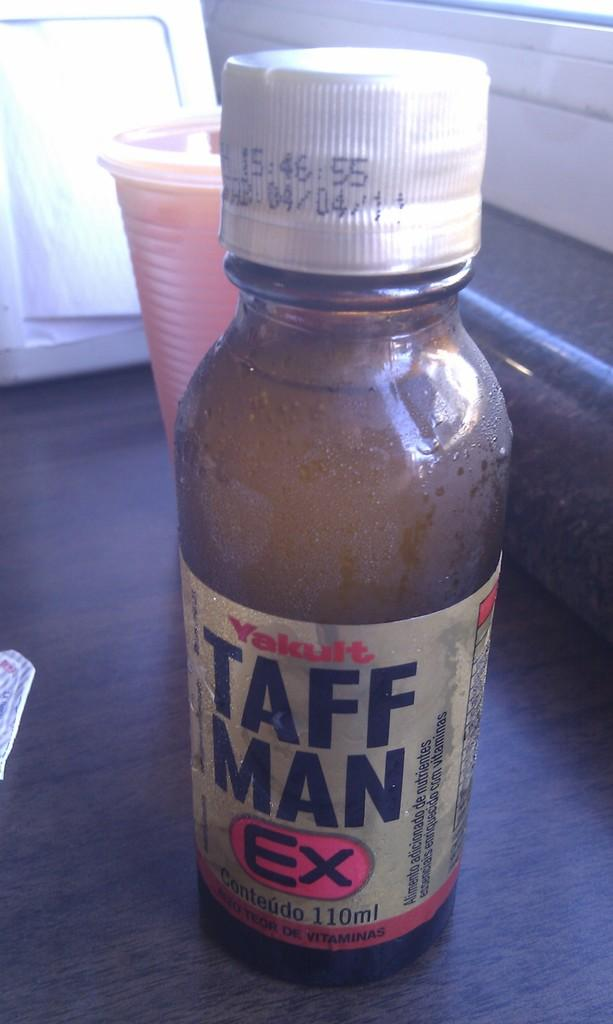<image>
Create a compact narrative representing the image presented. A bottled, which is labelled Taff Man Ex, is on a counter. 